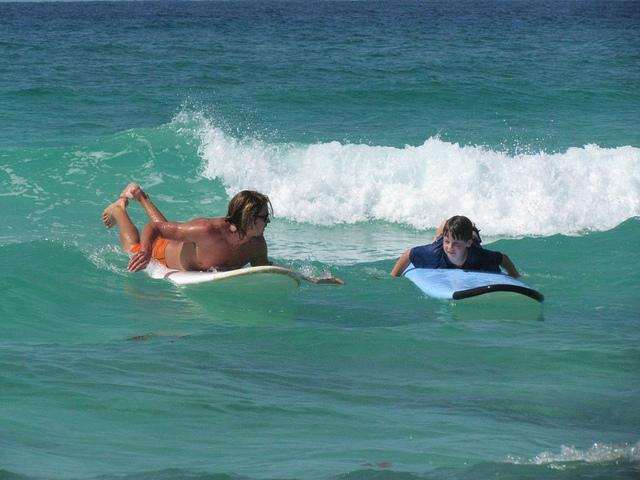Are these people married?
Give a very brief answer. No. Who has on orange?
Short answer required. Man. Are all the surfboards the same brand?
Keep it brief. No. Which person is younger?
Write a very short answer. One on right. Is the man wearing a shirt?
Answer briefly. No. How many people are in the water?
Quick response, please. 2. 